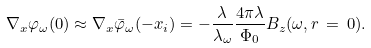<formula> <loc_0><loc_0><loc_500><loc_500>\nabla _ { x } \varphi _ { \omega } ( 0 ) \approx \nabla _ { x } \bar { \varphi } _ { \omega } ( - x _ { i } ) = - \frac { \lambda } { \lambda _ { \omega } } \frac { 4 \pi \lambda } { \Phi _ { 0 } } B _ { z } ( \omega , r \, = \, 0 ) .</formula> 